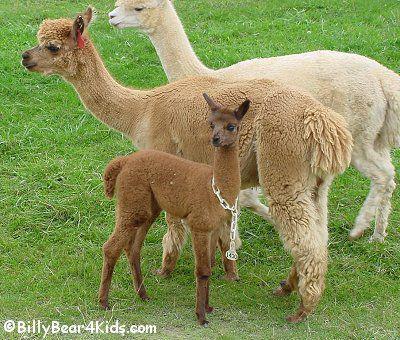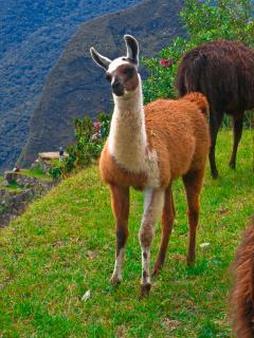The first image is the image on the left, the second image is the image on the right. Evaluate the accuracy of this statement regarding the images: "A juvenile llama can be seen near an adult llama.". Is it true? Answer yes or no. Yes. 